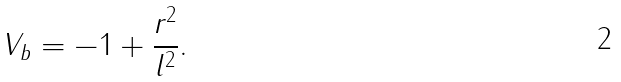<formula> <loc_0><loc_0><loc_500><loc_500>V _ { b } = - 1 + \frac { r ^ { 2 } } { l ^ { 2 } } .</formula> 